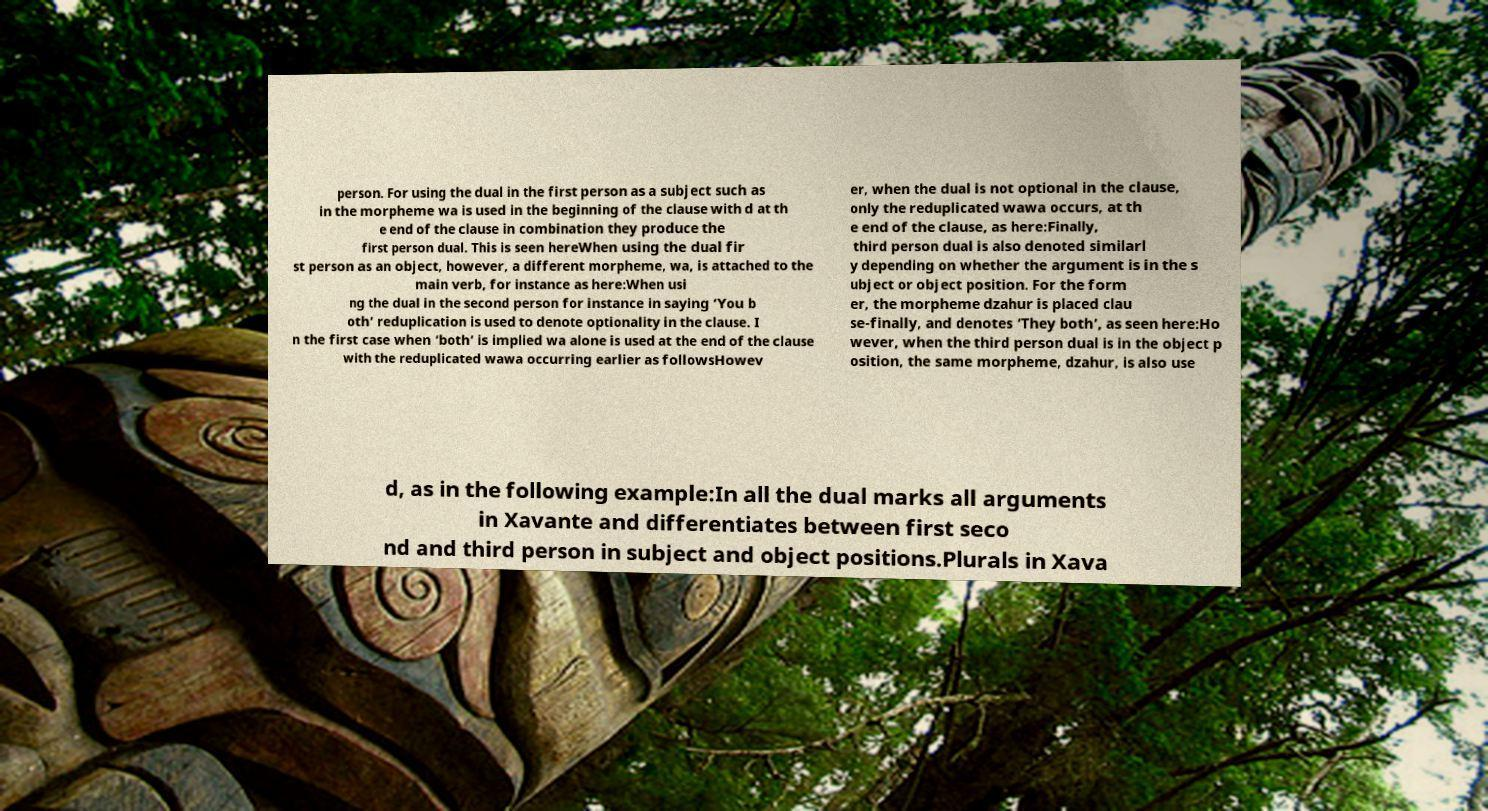I need the written content from this picture converted into text. Can you do that? person. For using the dual in the first person as a subject such as in the morpheme wa is used in the beginning of the clause with d at th e end of the clause in combination they produce the first person dual. This is seen hereWhen using the dual fir st person as an object, however, a different morpheme, wa, is attached to the main verb, for instance as here:When usi ng the dual in the second person for instance in saying ‘You b oth’ reduplication is used to denote optionality in the clause. I n the first case when ‘both’ is implied wa alone is used at the end of the clause with the reduplicated wawa occurring earlier as followsHowev er, when the dual is not optional in the clause, only the reduplicated wawa occurs, at th e end of the clause, as here:Finally, third person dual is also denoted similarl y depending on whether the argument is in the s ubject or object position. For the form er, the morpheme dzahur is placed clau se-finally, and denotes ‘They both’, as seen here:Ho wever, when the third person dual is in the object p osition, the same morpheme, dzahur, is also use d, as in the following example:In all the dual marks all arguments in Xavante and differentiates between first seco nd and third person in subject and object positions.Plurals in Xava 